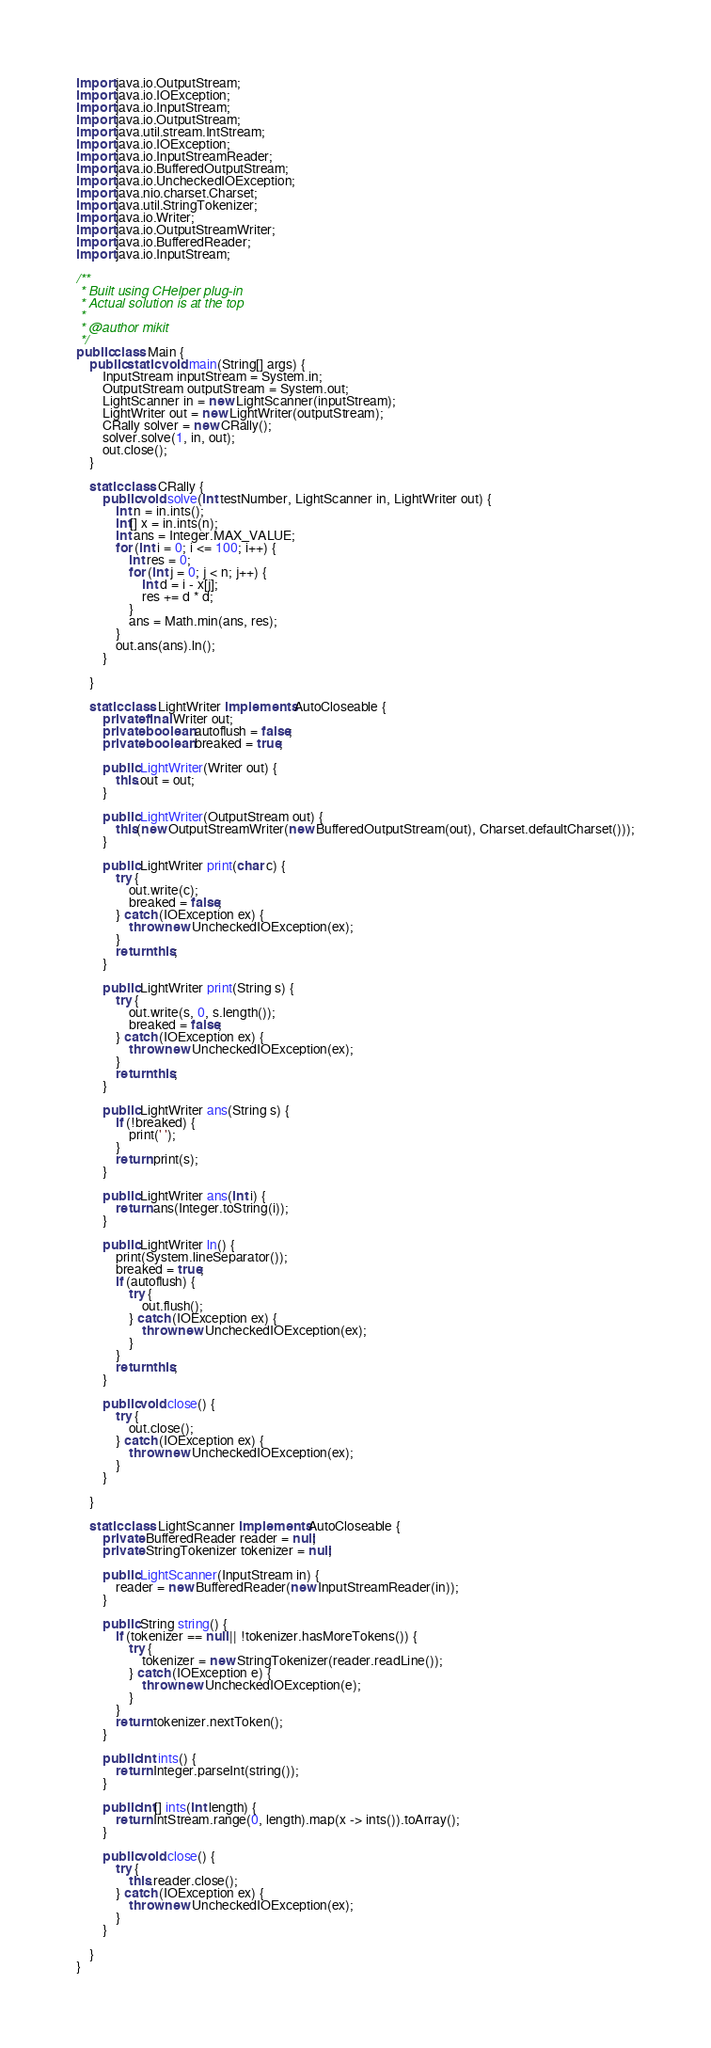Convert code to text. <code><loc_0><loc_0><loc_500><loc_500><_Java_>import java.io.OutputStream;
import java.io.IOException;
import java.io.InputStream;
import java.io.OutputStream;
import java.util.stream.IntStream;
import java.io.IOException;
import java.io.InputStreamReader;
import java.io.BufferedOutputStream;
import java.io.UncheckedIOException;
import java.nio.charset.Charset;
import java.util.StringTokenizer;
import java.io.Writer;
import java.io.OutputStreamWriter;
import java.io.BufferedReader;
import java.io.InputStream;

/**
 * Built using CHelper plug-in
 * Actual solution is at the top
 *
 * @author mikit
 */
public class Main {
    public static void main(String[] args) {
        InputStream inputStream = System.in;
        OutputStream outputStream = System.out;
        LightScanner in = new LightScanner(inputStream);
        LightWriter out = new LightWriter(outputStream);
        CRally solver = new CRally();
        solver.solve(1, in, out);
        out.close();
    }

    static class CRally {
        public void solve(int testNumber, LightScanner in, LightWriter out) {
            int n = in.ints();
            int[] x = in.ints(n);
            int ans = Integer.MAX_VALUE;
            for (int i = 0; i <= 100; i++) {
                int res = 0;
                for (int j = 0; j < n; j++) {
                    int d = i - x[j];
                    res += d * d;
                }
                ans = Math.min(ans, res);
            }
            out.ans(ans).ln();
        }

    }

    static class LightWriter implements AutoCloseable {
        private final Writer out;
        private boolean autoflush = false;
        private boolean breaked = true;

        public LightWriter(Writer out) {
            this.out = out;
        }

        public LightWriter(OutputStream out) {
            this(new OutputStreamWriter(new BufferedOutputStream(out), Charset.defaultCharset()));
        }

        public LightWriter print(char c) {
            try {
                out.write(c);
                breaked = false;
            } catch (IOException ex) {
                throw new UncheckedIOException(ex);
            }
            return this;
        }

        public LightWriter print(String s) {
            try {
                out.write(s, 0, s.length());
                breaked = false;
            } catch (IOException ex) {
                throw new UncheckedIOException(ex);
            }
            return this;
        }

        public LightWriter ans(String s) {
            if (!breaked) {
                print(' ');
            }
            return print(s);
        }

        public LightWriter ans(int i) {
            return ans(Integer.toString(i));
        }

        public LightWriter ln() {
            print(System.lineSeparator());
            breaked = true;
            if (autoflush) {
                try {
                    out.flush();
                } catch (IOException ex) {
                    throw new UncheckedIOException(ex);
                }
            }
            return this;
        }

        public void close() {
            try {
                out.close();
            } catch (IOException ex) {
                throw new UncheckedIOException(ex);
            }
        }

    }

    static class LightScanner implements AutoCloseable {
        private BufferedReader reader = null;
        private StringTokenizer tokenizer = null;

        public LightScanner(InputStream in) {
            reader = new BufferedReader(new InputStreamReader(in));
        }

        public String string() {
            if (tokenizer == null || !tokenizer.hasMoreTokens()) {
                try {
                    tokenizer = new StringTokenizer(reader.readLine());
                } catch (IOException e) {
                    throw new UncheckedIOException(e);
                }
            }
            return tokenizer.nextToken();
        }

        public int ints() {
            return Integer.parseInt(string());
        }

        public int[] ints(int length) {
            return IntStream.range(0, length).map(x -> ints()).toArray();
        }

        public void close() {
            try {
                this.reader.close();
            } catch (IOException ex) {
                throw new UncheckedIOException(ex);
            }
        }

    }
}

</code> 